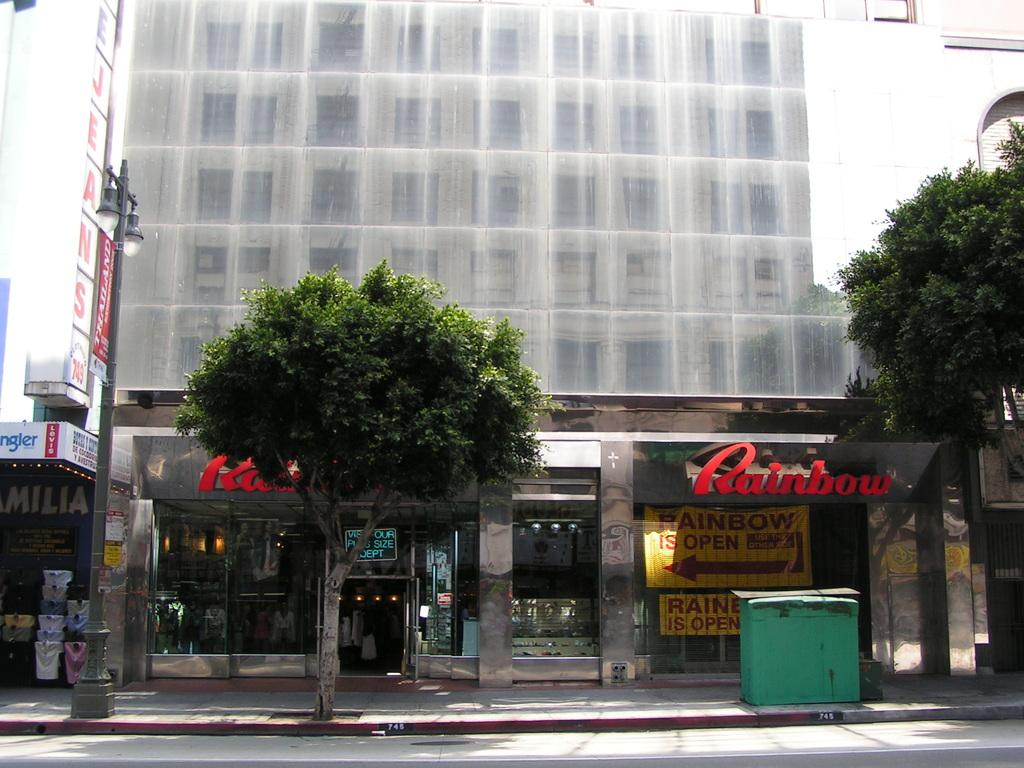What type of natural elements can be seen in the image? There are trees in the image. What man-made object is present on the footpath? There is a street light pole on the footpath. What can be seen in the distance in the image? There are buildings visible in the background. What word is written on the hoarding of a building in the image? The word "Rainbow" is written on the hoarding of a building. What type of account can be seen in the image? There is no account visible in the image. What authority is responsible for the street light pole in the image? The image does not provide information about the authority responsible for the street light pole. 